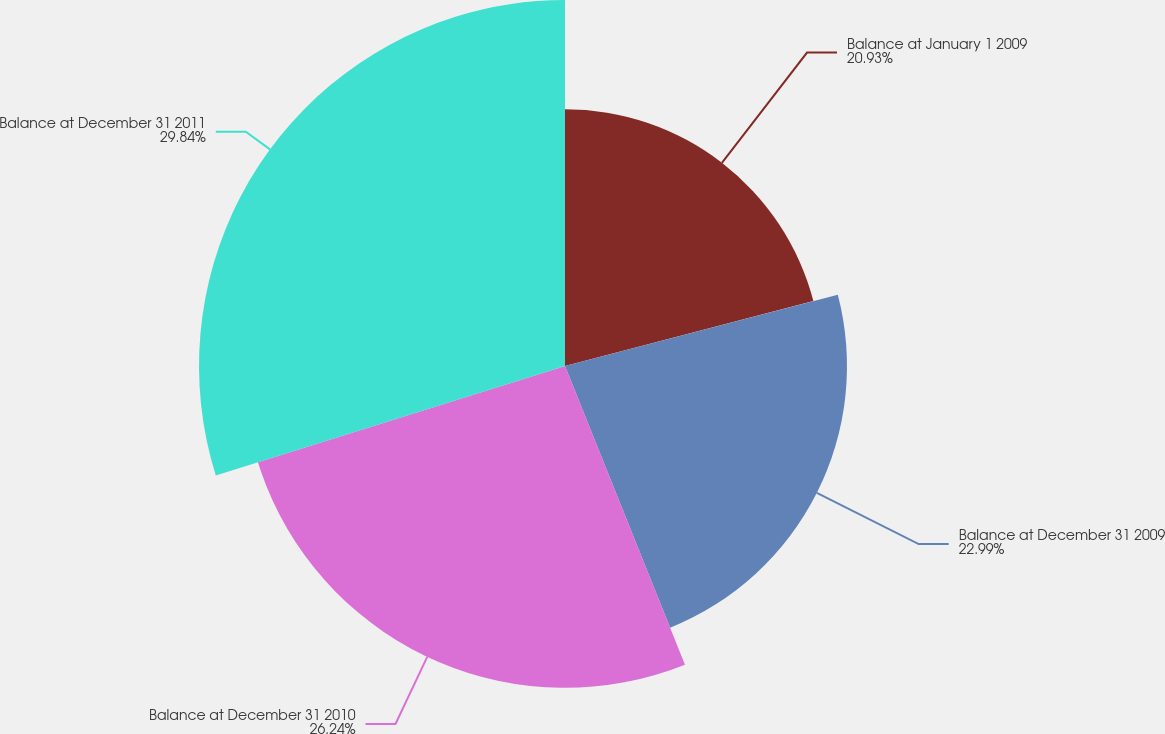Convert chart to OTSL. <chart><loc_0><loc_0><loc_500><loc_500><pie_chart><fcel>Balance at January 1 2009<fcel>Balance at December 31 2009<fcel>Balance at December 31 2010<fcel>Balance at December 31 2011<nl><fcel>20.93%<fcel>22.99%<fcel>26.24%<fcel>29.84%<nl></chart> 